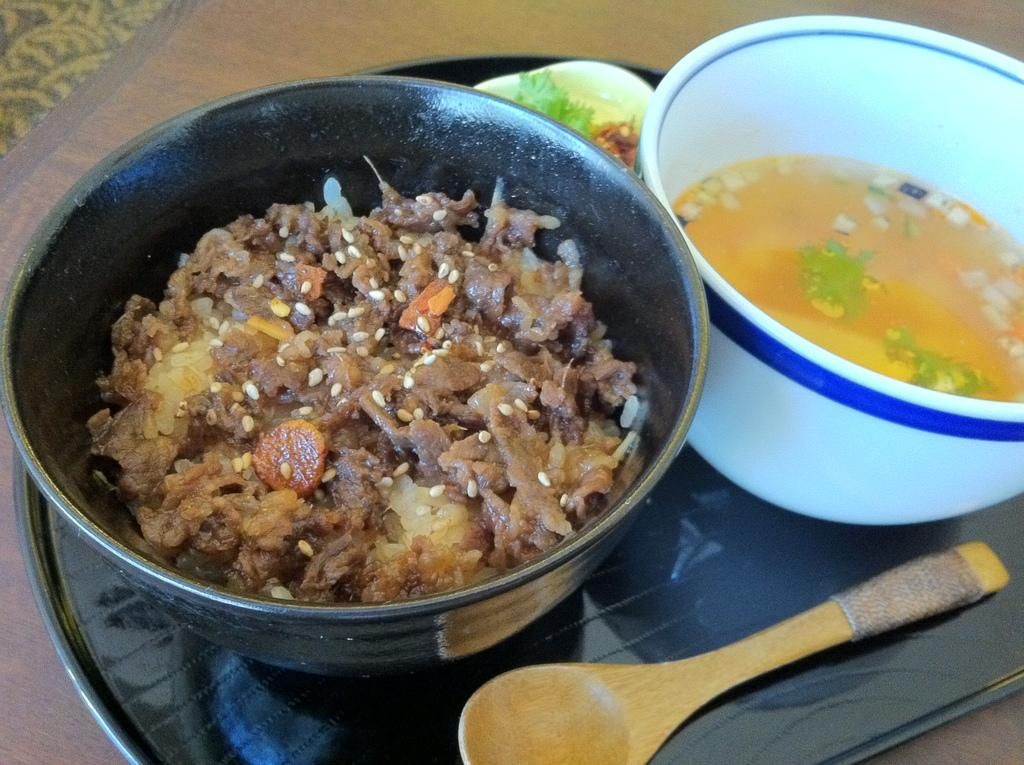What is placed on a wooden surface in the image? There is a tray on a wooden surface in the image. What can be found on the tray? There are bowls and a spoon on the tray. What type of food is in one of the bowls? There is soup in one of the bowls. What else is in the other bowl on the tray? There is food in another bowl on the tray. We start by identifying the main subject in the image, which is the tray on the wooden surface. Then, we expand the conversation to include the contents of the tray, such as the bowls and spoon. We also mention the specific types of food in the bowls, which are soup and another type of food. Each question is designed to elicit a specific detail about the image that is known from the provided facts. Absurd Question/Answer: Can you see a dog eating cake on the bed in the image? No, there is no dog, cake, or bed present in the image. Can you see a dog eating cake on the bed in the image? No, there is no dog, cake, or bed present in the image. 